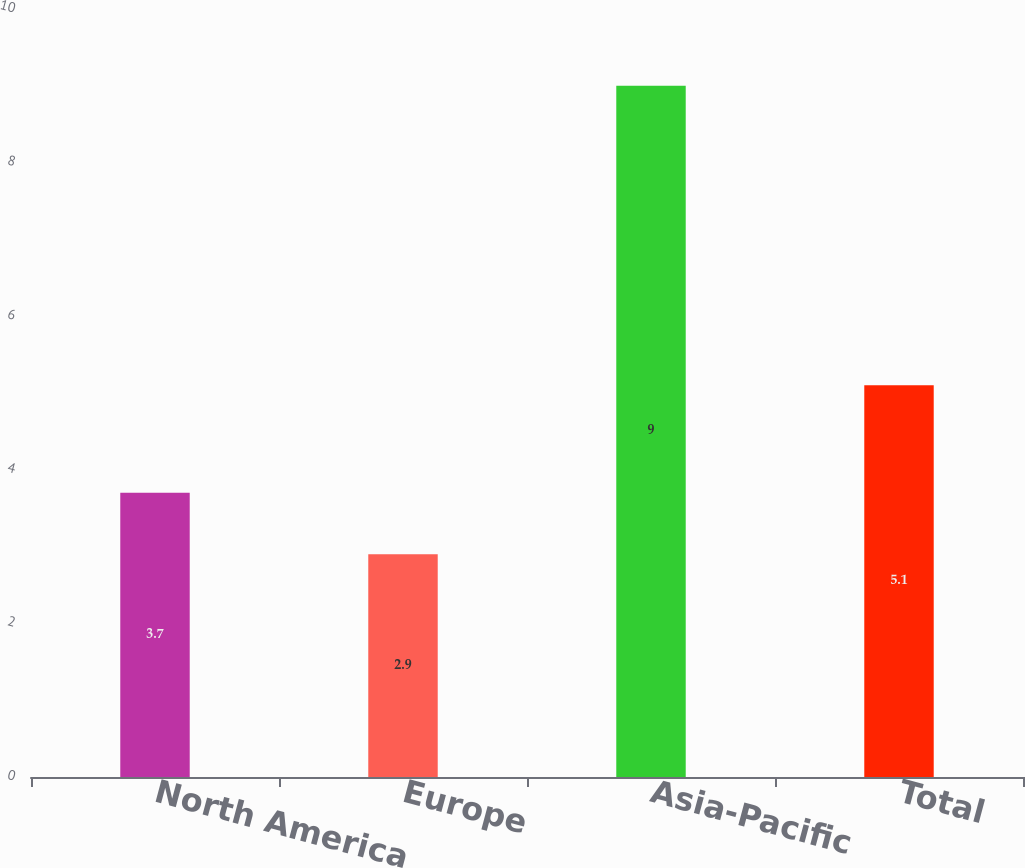<chart> <loc_0><loc_0><loc_500><loc_500><bar_chart><fcel>North America<fcel>Europe<fcel>Asia-Pacific<fcel>Total<nl><fcel>3.7<fcel>2.9<fcel>9<fcel>5.1<nl></chart> 